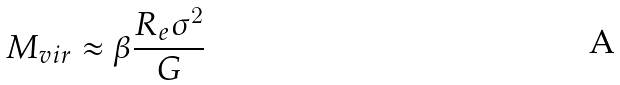Convert formula to latex. <formula><loc_0><loc_0><loc_500><loc_500>M _ { v i r } \approx \beta \frac { R _ { e } \sigma ^ { 2 } } { G }</formula> 